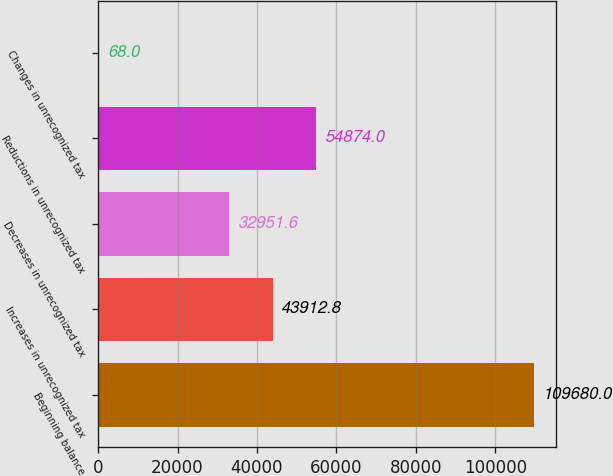Convert chart. <chart><loc_0><loc_0><loc_500><loc_500><bar_chart><fcel>Beginning balance<fcel>Increases in unrecognized tax<fcel>Decreases in unrecognized tax<fcel>Reductions in unrecognized tax<fcel>Changes in unrecognized tax<nl><fcel>109680<fcel>43912.8<fcel>32951.6<fcel>54874<fcel>68<nl></chart> 